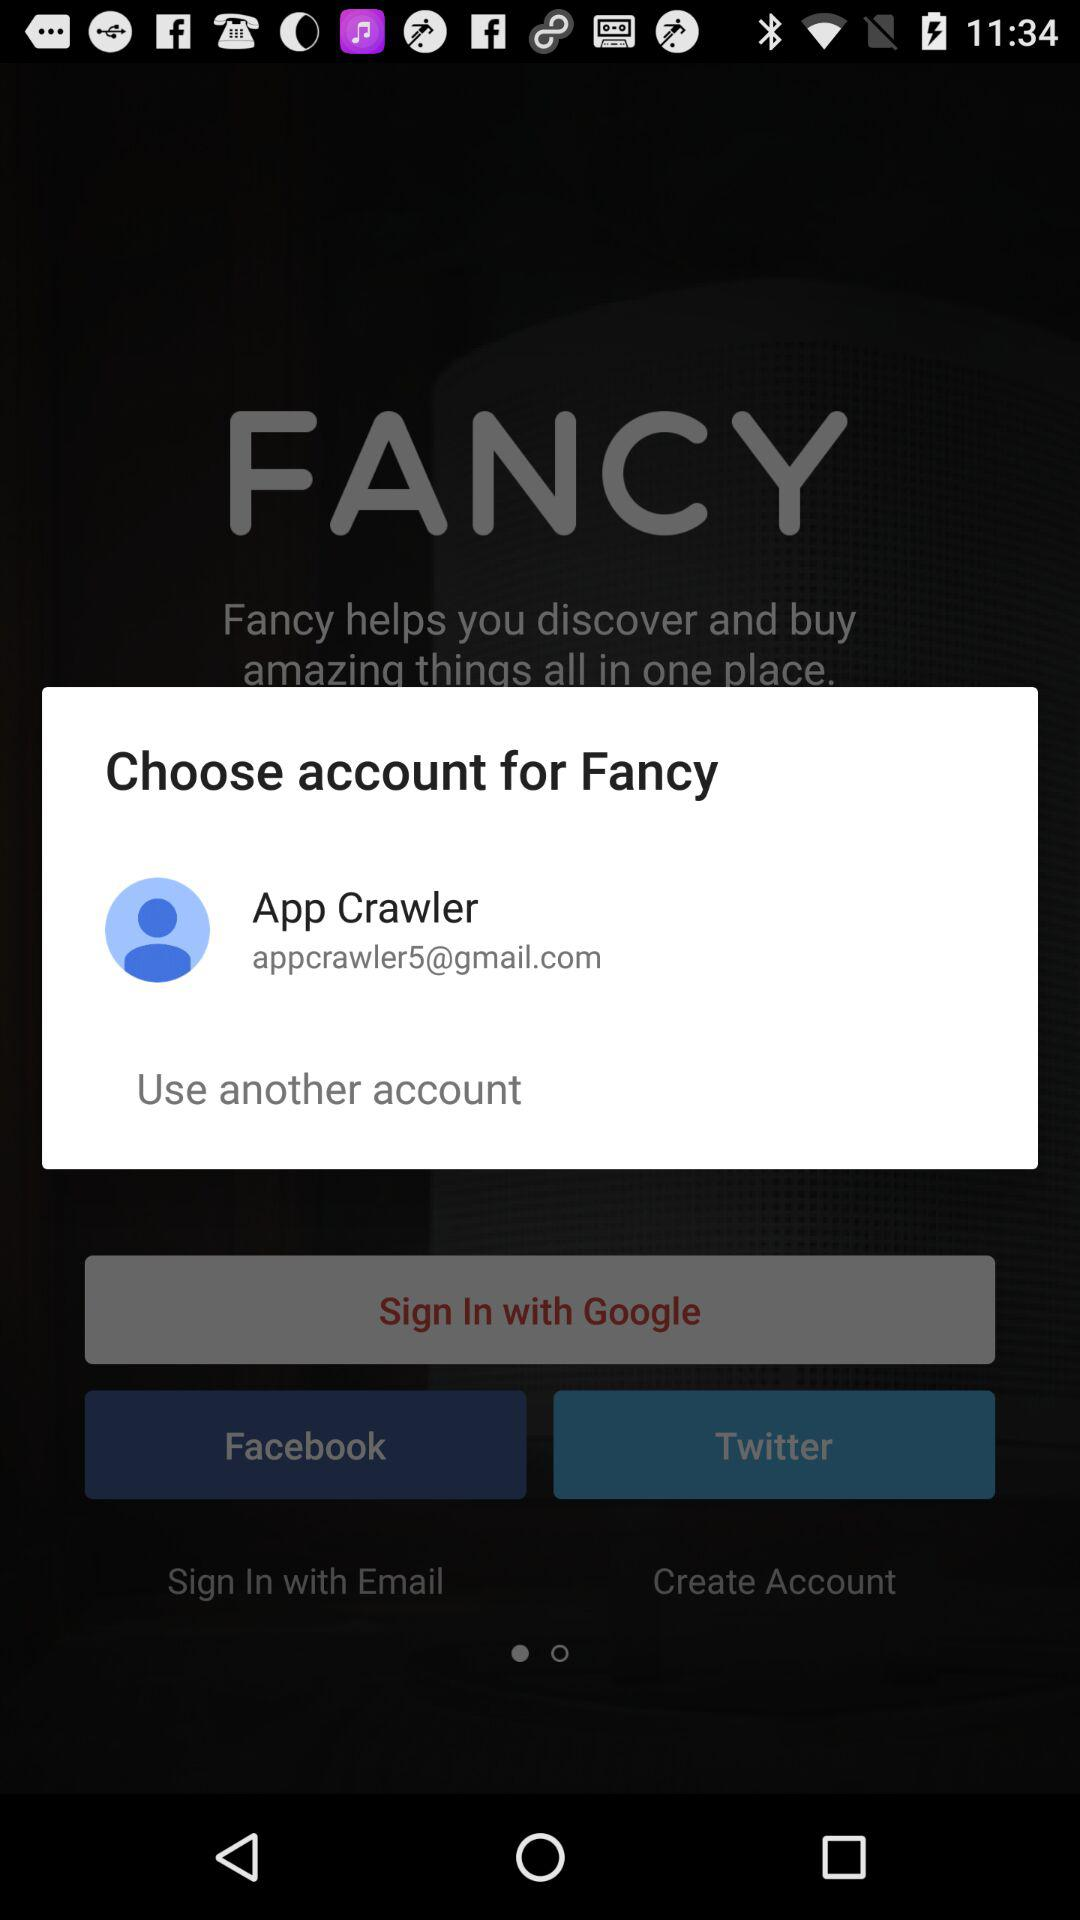What app can we use to sign in? The app is "Google". 